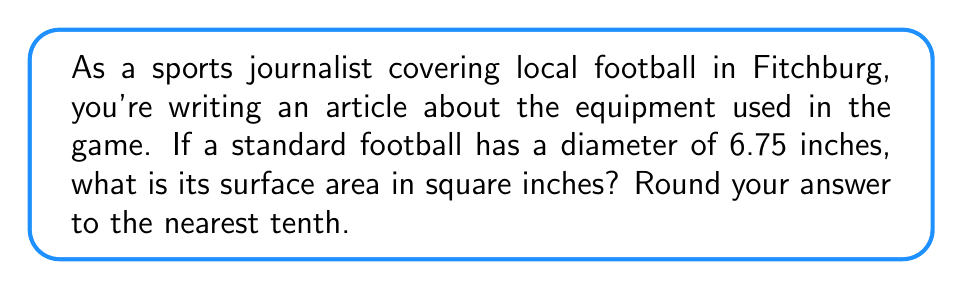Could you help me with this problem? Let's approach this step-by-step:

1) The formula for the surface area of a sphere is:
   $$A = 4\pi r^2$$
   where $A$ is the surface area and $r$ is the radius.

2) We're given the diameter, which is 6.75 inches. To find the radius, we divide the diameter by 2:
   $$r = \frac{6.75}{2} = 3.375\text{ inches}$$

3) Now we can substitute this into our formula:
   $$A = 4\pi (3.375)^2$$

4) Let's calculate this:
   $$A = 4\pi (11.390625)$$
   $$A = 45.5625\pi$$

5) Using 3.14159 as an approximation for $\pi$:
   $$A \approx 45.5625 * 3.14159$$
   $$A \approx 143.1394\text{ square inches}$$

6) Rounding to the nearest tenth:
   $$A \approx 143.1\text{ square inches}$$
Answer: $143.1\text{ in}^2$ 